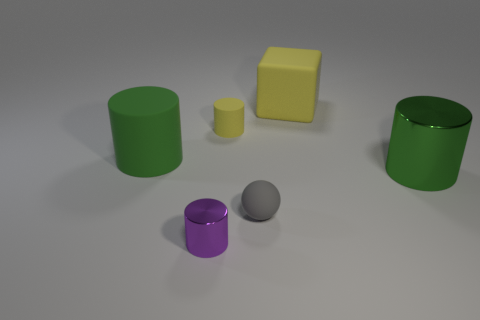Subtract all green shiny cylinders. How many cylinders are left? 3 Subtract all cylinders. How many objects are left? 2 Add 2 big blocks. How many objects exist? 8 Subtract all purple cylinders. How many cylinders are left? 3 Subtract all gray balls. How many gray cylinders are left? 0 Subtract all small balls. Subtract all green matte objects. How many objects are left? 4 Add 6 small rubber cylinders. How many small rubber cylinders are left? 7 Add 3 gray balls. How many gray balls exist? 4 Subtract 0 red blocks. How many objects are left? 6 Subtract all blue cubes. Subtract all gray spheres. How many cubes are left? 1 